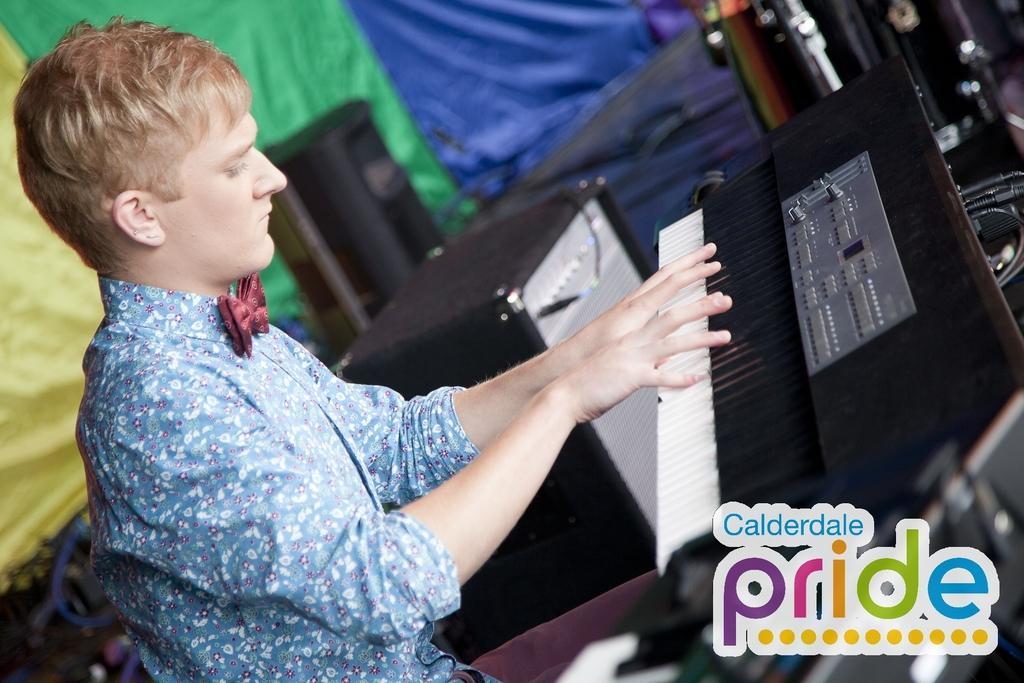Describe this image in one or two sentences. In this image I can see a person playing the musical instrument. In this image I can also see some sound boxes. At the back there is a cloth 